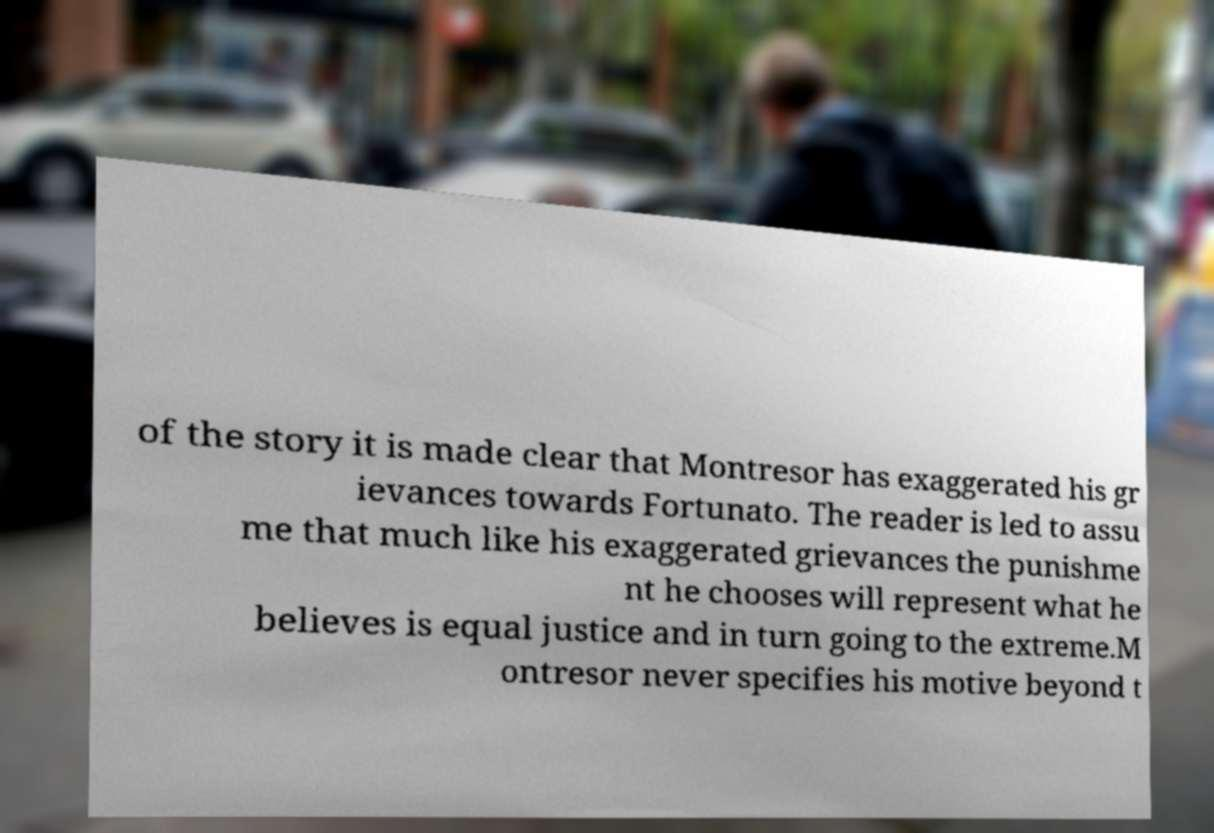I need the written content from this picture converted into text. Can you do that? of the story it is made clear that Montresor has exaggerated his gr ievances towards Fortunato. The reader is led to assu me that much like his exaggerated grievances the punishme nt he chooses will represent what he believes is equal justice and in turn going to the extreme.M ontresor never specifies his motive beyond t 